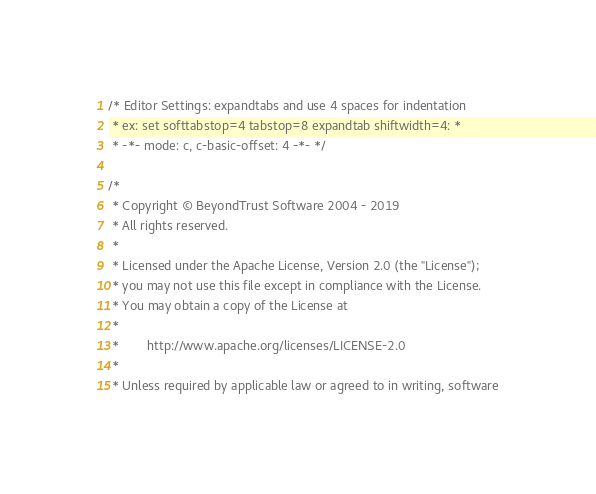Convert code to text. <code><loc_0><loc_0><loc_500><loc_500><_C_>/* Editor Settings: expandtabs and use 4 spaces for indentation
 * ex: set softtabstop=4 tabstop=8 expandtab shiftwidth=4: *
 * -*- mode: c, c-basic-offset: 4 -*- */

/*
 * Copyright © BeyondTrust Software 2004 - 2019
 * All rights reserved.
 *
 * Licensed under the Apache License, Version 2.0 (the "License");
 * you may not use this file except in compliance with the License.
 * You may obtain a copy of the License at
 *
 *        http://www.apache.org/licenses/LICENSE-2.0
 *
 * Unless required by applicable law or agreed to in writing, software</code> 